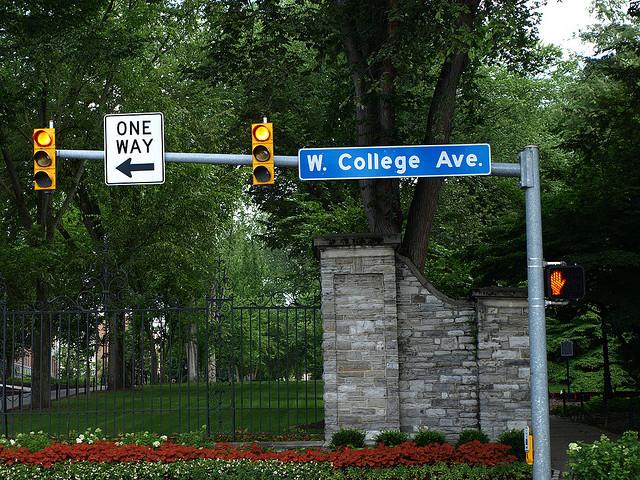What type of school is that?
Give a very brief answer. College. Does the sign say to walk across the street?
Answer briefly. No. What does the white sign say?
Quick response, please. One way. 